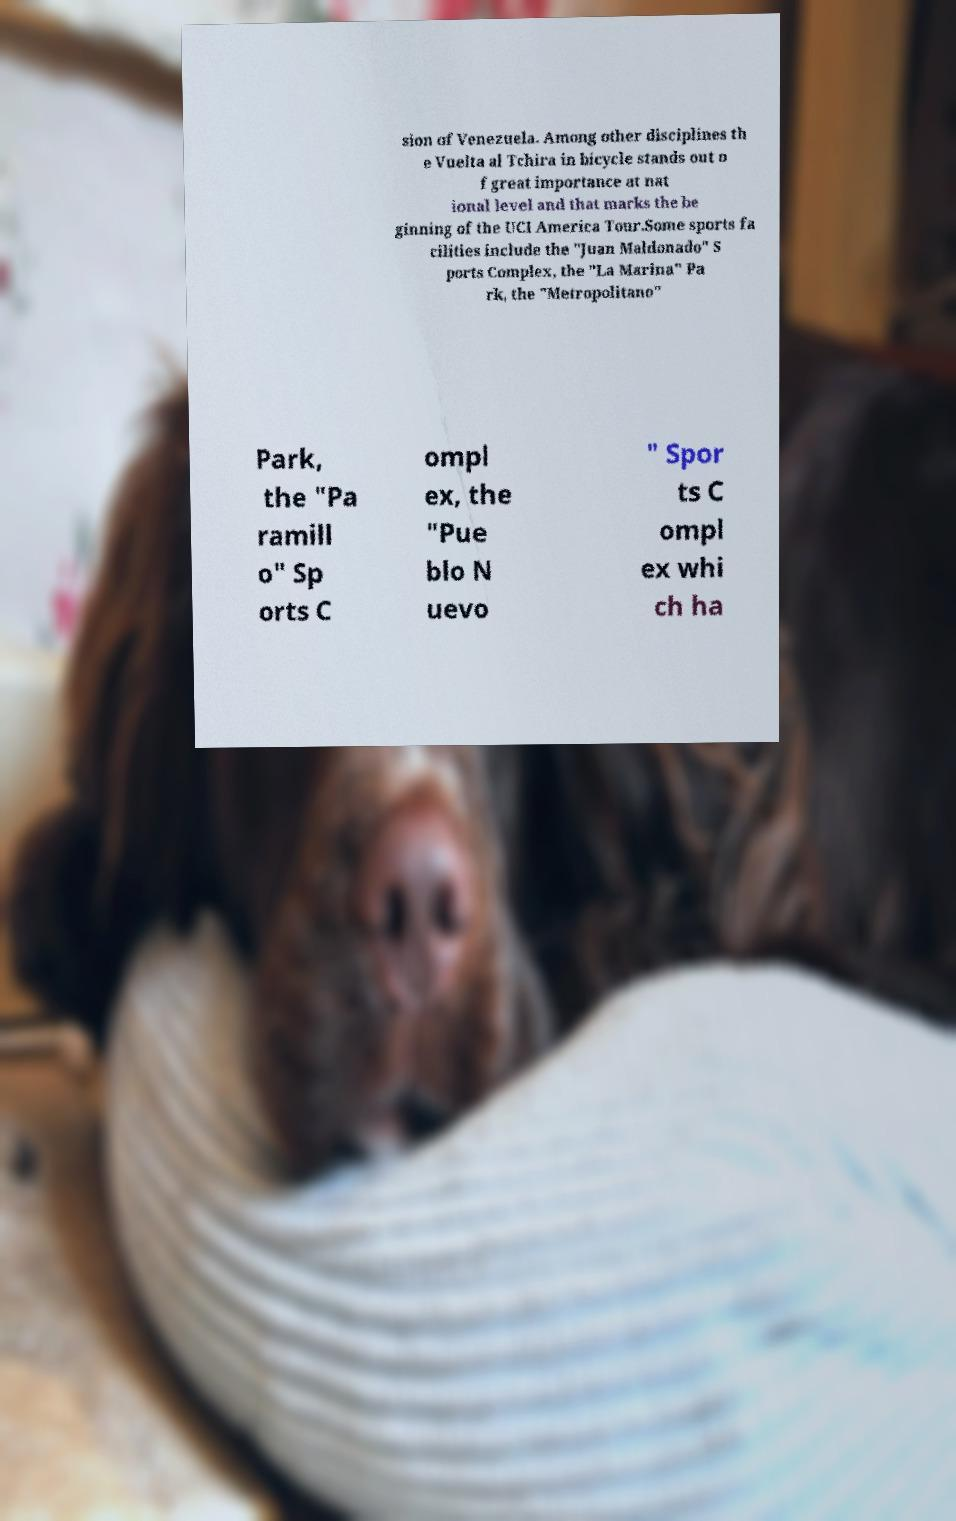There's text embedded in this image that I need extracted. Can you transcribe it verbatim? sion of Venezuela. Among other disciplines th e Vuelta al Tchira in bicycle stands out o f great importance at nat ional level and that marks the be ginning of the UCI America Tour.Some sports fa cilities include the "Juan Maldonado" S ports Complex, the "La Marina" Pa rk, the "Metropolitano" Park, the "Pa ramill o" Sp orts C ompl ex, the "Pue blo N uevo " Spor ts C ompl ex whi ch ha 